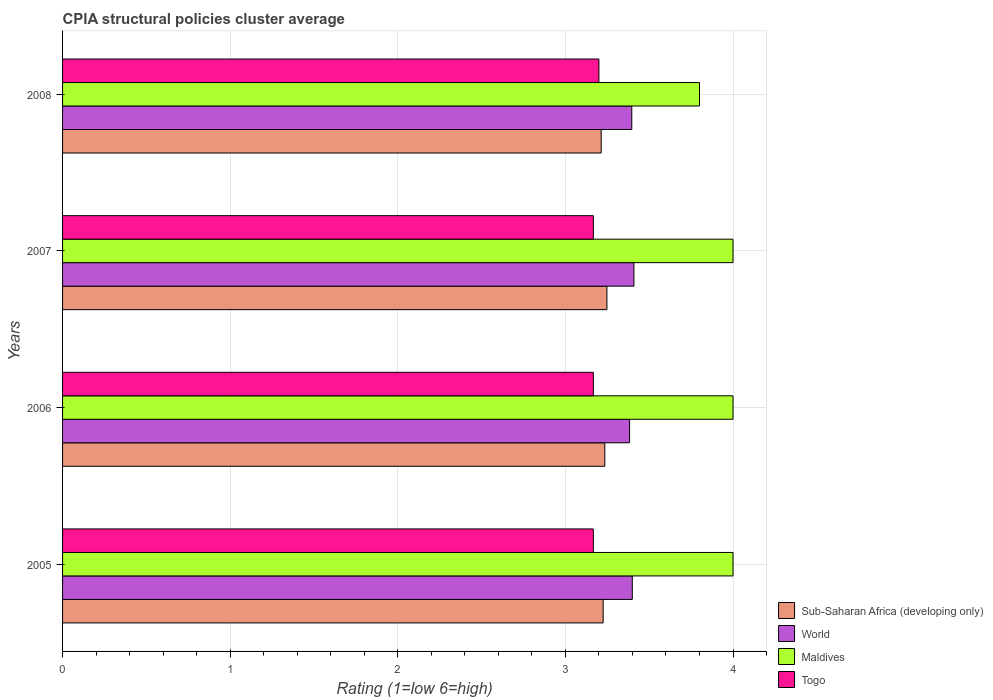How many groups of bars are there?
Your answer should be very brief. 4. Are the number of bars on each tick of the Y-axis equal?
Give a very brief answer. Yes. How many bars are there on the 4th tick from the bottom?
Offer a very short reply. 4. What is the CPIA rating in Maldives in 2005?
Your response must be concise. 4. Across all years, what is the maximum CPIA rating in Sub-Saharan Africa (developing only)?
Offer a terse response. 3.25. In which year was the CPIA rating in World maximum?
Your answer should be compact. 2007. What is the total CPIA rating in Sub-Saharan Africa (developing only) in the graph?
Make the answer very short. 12.92. What is the difference between the CPIA rating in World in 2005 and that in 2008?
Ensure brevity in your answer.  0. What is the difference between the CPIA rating in Togo in 2005 and the CPIA rating in Maldives in 2007?
Make the answer very short. -0.83. What is the average CPIA rating in World per year?
Provide a succinct answer. 3.4. In the year 2006, what is the difference between the CPIA rating in Maldives and CPIA rating in Togo?
Offer a very short reply. 0.83. In how many years, is the CPIA rating in Togo greater than 0.6000000000000001 ?
Your response must be concise. 4. What is the ratio of the CPIA rating in Togo in 2005 to that in 2008?
Offer a terse response. 0.99. Is the CPIA rating in Maldives in 2007 less than that in 2008?
Your answer should be very brief. No. What is the difference between the highest and the second highest CPIA rating in World?
Keep it short and to the point. 0.01. What is the difference between the highest and the lowest CPIA rating in Maldives?
Keep it short and to the point. 0.2. What does the 4th bar from the bottom in 2007 represents?
Offer a very short reply. Togo. How many bars are there?
Ensure brevity in your answer.  16. How many years are there in the graph?
Keep it short and to the point. 4. Does the graph contain any zero values?
Your response must be concise. No. Does the graph contain grids?
Keep it short and to the point. Yes. How are the legend labels stacked?
Make the answer very short. Vertical. What is the title of the graph?
Your answer should be compact. CPIA structural policies cluster average. What is the label or title of the X-axis?
Offer a very short reply. Rating (1=low 6=high). What is the label or title of the Y-axis?
Keep it short and to the point. Years. What is the Rating (1=low 6=high) of Sub-Saharan Africa (developing only) in 2005?
Provide a succinct answer. 3.23. What is the Rating (1=low 6=high) of World in 2005?
Ensure brevity in your answer.  3.4. What is the Rating (1=low 6=high) in Togo in 2005?
Ensure brevity in your answer.  3.17. What is the Rating (1=low 6=high) of Sub-Saharan Africa (developing only) in 2006?
Your answer should be compact. 3.24. What is the Rating (1=low 6=high) of World in 2006?
Give a very brief answer. 3.38. What is the Rating (1=low 6=high) in Togo in 2006?
Make the answer very short. 3.17. What is the Rating (1=low 6=high) in Sub-Saharan Africa (developing only) in 2007?
Keep it short and to the point. 3.25. What is the Rating (1=low 6=high) of World in 2007?
Make the answer very short. 3.41. What is the Rating (1=low 6=high) in Togo in 2007?
Ensure brevity in your answer.  3.17. What is the Rating (1=low 6=high) in Sub-Saharan Africa (developing only) in 2008?
Provide a succinct answer. 3.21. What is the Rating (1=low 6=high) of World in 2008?
Offer a very short reply. 3.4. What is the Rating (1=low 6=high) in Maldives in 2008?
Offer a very short reply. 3.8. What is the Rating (1=low 6=high) in Togo in 2008?
Offer a very short reply. 3.2. Across all years, what is the maximum Rating (1=low 6=high) in Sub-Saharan Africa (developing only)?
Your answer should be compact. 3.25. Across all years, what is the maximum Rating (1=low 6=high) of World?
Your answer should be very brief. 3.41. Across all years, what is the maximum Rating (1=low 6=high) of Togo?
Your answer should be compact. 3.2. Across all years, what is the minimum Rating (1=low 6=high) in Sub-Saharan Africa (developing only)?
Keep it short and to the point. 3.21. Across all years, what is the minimum Rating (1=low 6=high) in World?
Your response must be concise. 3.38. Across all years, what is the minimum Rating (1=low 6=high) in Maldives?
Provide a short and direct response. 3.8. Across all years, what is the minimum Rating (1=low 6=high) in Togo?
Your response must be concise. 3.17. What is the total Rating (1=low 6=high) in Sub-Saharan Africa (developing only) in the graph?
Offer a very short reply. 12.92. What is the total Rating (1=low 6=high) of World in the graph?
Give a very brief answer. 13.59. What is the difference between the Rating (1=low 6=high) in Sub-Saharan Africa (developing only) in 2005 and that in 2006?
Offer a terse response. -0.01. What is the difference between the Rating (1=low 6=high) in World in 2005 and that in 2006?
Keep it short and to the point. 0.02. What is the difference between the Rating (1=low 6=high) of Maldives in 2005 and that in 2006?
Provide a succinct answer. 0. What is the difference between the Rating (1=low 6=high) in Togo in 2005 and that in 2006?
Provide a short and direct response. 0. What is the difference between the Rating (1=low 6=high) in Sub-Saharan Africa (developing only) in 2005 and that in 2007?
Offer a very short reply. -0.02. What is the difference between the Rating (1=low 6=high) of World in 2005 and that in 2007?
Give a very brief answer. -0.01. What is the difference between the Rating (1=low 6=high) of Sub-Saharan Africa (developing only) in 2005 and that in 2008?
Make the answer very short. 0.01. What is the difference between the Rating (1=low 6=high) in World in 2005 and that in 2008?
Provide a succinct answer. 0. What is the difference between the Rating (1=low 6=high) in Togo in 2005 and that in 2008?
Your answer should be compact. -0.03. What is the difference between the Rating (1=low 6=high) in Sub-Saharan Africa (developing only) in 2006 and that in 2007?
Provide a succinct answer. -0.01. What is the difference between the Rating (1=low 6=high) of World in 2006 and that in 2007?
Provide a short and direct response. -0.03. What is the difference between the Rating (1=low 6=high) in Sub-Saharan Africa (developing only) in 2006 and that in 2008?
Keep it short and to the point. 0.02. What is the difference between the Rating (1=low 6=high) of World in 2006 and that in 2008?
Offer a terse response. -0.01. What is the difference between the Rating (1=low 6=high) of Maldives in 2006 and that in 2008?
Offer a very short reply. 0.2. What is the difference between the Rating (1=low 6=high) of Togo in 2006 and that in 2008?
Ensure brevity in your answer.  -0.03. What is the difference between the Rating (1=low 6=high) of Sub-Saharan Africa (developing only) in 2007 and that in 2008?
Your answer should be compact. 0.03. What is the difference between the Rating (1=low 6=high) of World in 2007 and that in 2008?
Your answer should be very brief. 0.01. What is the difference between the Rating (1=low 6=high) in Togo in 2007 and that in 2008?
Make the answer very short. -0.03. What is the difference between the Rating (1=low 6=high) in Sub-Saharan Africa (developing only) in 2005 and the Rating (1=low 6=high) in World in 2006?
Offer a very short reply. -0.16. What is the difference between the Rating (1=low 6=high) of Sub-Saharan Africa (developing only) in 2005 and the Rating (1=low 6=high) of Maldives in 2006?
Offer a terse response. -0.77. What is the difference between the Rating (1=low 6=high) of Sub-Saharan Africa (developing only) in 2005 and the Rating (1=low 6=high) of Togo in 2006?
Ensure brevity in your answer.  0.06. What is the difference between the Rating (1=low 6=high) in World in 2005 and the Rating (1=low 6=high) in Maldives in 2006?
Ensure brevity in your answer.  -0.6. What is the difference between the Rating (1=low 6=high) in World in 2005 and the Rating (1=low 6=high) in Togo in 2006?
Your answer should be very brief. 0.23. What is the difference between the Rating (1=low 6=high) of Sub-Saharan Africa (developing only) in 2005 and the Rating (1=low 6=high) of World in 2007?
Ensure brevity in your answer.  -0.18. What is the difference between the Rating (1=low 6=high) in Sub-Saharan Africa (developing only) in 2005 and the Rating (1=low 6=high) in Maldives in 2007?
Provide a succinct answer. -0.77. What is the difference between the Rating (1=low 6=high) in Sub-Saharan Africa (developing only) in 2005 and the Rating (1=low 6=high) in Togo in 2007?
Keep it short and to the point. 0.06. What is the difference between the Rating (1=low 6=high) of World in 2005 and the Rating (1=low 6=high) of Maldives in 2007?
Provide a succinct answer. -0.6. What is the difference between the Rating (1=low 6=high) in World in 2005 and the Rating (1=low 6=high) in Togo in 2007?
Keep it short and to the point. 0.23. What is the difference between the Rating (1=low 6=high) of Maldives in 2005 and the Rating (1=low 6=high) of Togo in 2007?
Offer a very short reply. 0.83. What is the difference between the Rating (1=low 6=high) of Sub-Saharan Africa (developing only) in 2005 and the Rating (1=low 6=high) of World in 2008?
Make the answer very short. -0.17. What is the difference between the Rating (1=low 6=high) in Sub-Saharan Africa (developing only) in 2005 and the Rating (1=low 6=high) in Maldives in 2008?
Ensure brevity in your answer.  -0.57. What is the difference between the Rating (1=low 6=high) in Sub-Saharan Africa (developing only) in 2005 and the Rating (1=low 6=high) in Togo in 2008?
Your response must be concise. 0.03. What is the difference between the Rating (1=low 6=high) of World in 2005 and the Rating (1=low 6=high) of Maldives in 2008?
Make the answer very short. -0.4. What is the difference between the Rating (1=low 6=high) in World in 2005 and the Rating (1=low 6=high) in Togo in 2008?
Keep it short and to the point. 0.2. What is the difference between the Rating (1=low 6=high) in Maldives in 2005 and the Rating (1=low 6=high) in Togo in 2008?
Make the answer very short. 0.8. What is the difference between the Rating (1=low 6=high) in Sub-Saharan Africa (developing only) in 2006 and the Rating (1=low 6=high) in World in 2007?
Provide a succinct answer. -0.17. What is the difference between the Rating (1=low 6=high) in Sub-Saharan Africa (developing only) in 2006 and the Rating (1=low 6=high) in Maldives in 2007?
Provide a succinct answer. -0.76. What is the difference between the Rating (1=low 6=high) of Sub-Saharan Africa (developing only) in 2006 and the Rating (1=low 6=high) of Togo in 2007?
Provide a succinct answer. 0.07. What is the difference between the Rating (1=low 6=high) in World in 2006 and the Rating (1=low 6=high) in Maldives in 2007?
Your response must be concise. -0.62. What is the difference between the Rating (1=low 6=high) in World in 2006 and the Rating (1=low 6=high) in Togo in 2007?
Your response must be concise. 0.22. What is the difference between the Rating (1=low 6=high) of Sub-Saharan Africa (developing only) in 2006 and the Rating (1=low 6=high) of World in 2008?
Keep it short and to the point. -0.16. What is the difference between the Rating (1=low 6=high) of Sub-Saharan Africa (developing only) in 2006 and the Rating (1=low 6=high) of Maldives in 2008?
Your answer should be compact. -0.56. What is the difference between the Rating (1=low 6=high) of Sub-Saharan Africa (developing only) in 2006 and the Rating (1=low 6=high) of Togo in 2008?
Your answer should be compact. 0.04. What is the difference between the Rating (1=low 6=high) in World in 2006 and the Rating (1=low 6=high) in Maldives in 2008?
Provide a short and direct response. -0.42. What is the difference between the Rating (1=low 6=high) of World in 2006 and the Rating (1=low 6=high) of Togo in 2008?
Your answer should be very brief. 0.18. What is the difference between the Rating (1=low 6=high) of Sub-Saharan Africa (developing only) in 2007 and the Rating (1=low 6=high) of World in 2008?
Your response must be concise. -0.15. What is the difference between the Rating (1=low 6=high) of Sub-Saharan Africa (developing only) in 2007 and the Rating (1=low 6=high) of Maldives in 2008?
Give a very brief answer. -0.55. What is the difference between the Rating (1=low 6=high) in Sub-Saharan Africa (developing only) in 2007 and the Rating (1=low 6=high) in Togo in 2008?
Provide a succinct answer. 0.05. What is the difference between the Rating (1=low 6=high) of World in 2007 and the Rating (1=low 6=high) of Maldives in 2008?
Provide a succinct answer. -0.39. What is the difference between the Rating (1=low 6=high) in World in 2007 and the Rating (1=low 6=high) in Togo in 2008?
Provide a short and direct response. 0.21. What is the average Rating (1=low 6=high) in Sub-Saharan Africa (developing only) per year?
Offer a very short reply. 3.23. What is the average Rating (1=low 6=high) in World per year?
Your answer should be very brief. 3.4. What is the average Rating (1=low 6=high) in Maldives per year?
Provide a succinct answer. 3.95. What is the average Rating (1=low 6=high) of Togo per year?
Offer a terse response. 3.17. In the year 2005, what is the difference between the Rating (1=low 6=high) in Sub-Saharan Africa (developing only) and Rating (1=low 6=high) in World?
Make the answer very short. -0.17. In the year 2005, what is the difference between the Rating (1=low 6=high) in Sub-Saharan Africa (developing only) and Rating (1=low 6=high) in Maldives?
Keep it short and to the point. -0.77. In the year 2005, what is the difference between the Rating (1=low 6=high) of Sub-Saharan Africa (developing only) and Rating (1=low 6=high) of Togo?
Provide a succinct answer. 0.06. In the year 2005, what is the difference between the Rating (1=low 6=high) in World and Rating (1=low 6=high) in Maldives?
Keep it short and to the point. -0.6. In the year 2005, what is the difference between the Rating (1=low 6=high) in World and Rating (1=low 6=high) in Togo?
Make the answer very short. 0.23. In the year 2006, what is the difference between the Rating (1=low 6=high) of Sub-Saharan Africa (developing only) and Rating (1=low 6=high) of World?
Offer a terse response. -0.15. In the year 2006, what is the difference between the Rating (1=low 6=high) in Sub-Saharan Africa (developing only) and Rating (1=low 6=high) in Maldives?
Provide a succinct answer. -0.76. In the year 2006, what is the difference between the Rating (1=low 6=high) of Sub-Saharan Africa (developing only) and Rating (1=low 6=high) of Togo?
Provide a succinct answer. 0.07. In the year 2006, what is the difference between the Rating (1=low 6=high) in World and Rating (1=low 6=high) in Maldives?
Your answer should be compact. -0.62. In the year 2006, what is the difference between the Rating (1=low 6=high) of World and Rating (1=low 6=high) of Togo?
Make the answer very short. 0.22. In the year 2006, what is the difference between the Rating (1=low 6=high) in Maldives and Rating (1=low 6=high) in Togo?
Make the answer very short. 0.83. In the year 2007, what is the difference between the Rating (1=low 6=high) in Sub-Saharan Africa (developing only) and Rating (1=low 6=high) in World?
Your answer should be compact. -0.16. In the year 2007, what is the difference between the Rating (1=low 6=high) in Sub-Saharan Africa (developing only) and Rating (1=low 6=high) in Maldives?
Keep it short and to the point. -0.75. In the year 2007, what is the difference between the Rating (1=low 6=high) in Sub-Saharan Africa (developing only) and Rating (1=low 6=high) in Togo?
Your answer should be very brief. 0.08. In the year 2007, what is the difference between the Rating (1=low 6=high) of World and Rating (1=low 6=high) of Maldives?
Offer a very short reply. -0.59. In the year 2007, what is the difference between the Rating (1=low 6=high) in World and Rating (1=low 6=high) in Togo?
Offer a terse response. 0.24. In the year 2008, what is the difference between the Rating (1=low 6=high) in Sub-Saharan Africa (developing only) and Rating (1=low 6=high) in World?
Offer a terse response. -0.18. In the year 2008, what is the difference between the Rating (1=low 6=high) of Sub-Saharan Africa (developing only) and Rating (1=low 6=high) of Maldives?
Give a very brief answer. -0.59. In the year 2008, what is the difference between the Rating (1=low 6=high) in Sub-Saharan Africa (developing only) and Rating (1=low 6=high) in Togo?
Ensure brevity in your answer.  0.01. In the year 2008, what is the difference between the Rating (1=low 6=high) of World and Rating (1=low 6=high) of Maldives?
Your answer should be compact. -0.4. In the year 2008, what is the difference between the Rating (1=low 6=high) of World and Rating (1=low 6=high) of Togo?
Offer a very short reply. 0.2. In the year 2008, what is the difference between the Rating (1=low 6=high) in Maldives and Rating (1=low 6=high) in Togo?
Your answer should be very brief. 0.6. What is the ratio of the Rating (1=low 6=high) in Sub-Saharan Africa (developing only) in 2005 to that in 2006?
Provide a succinct answer. 1. What is the ratio of the Rating (1=low 6=high) in Maldives in 2005 to that in 2006?
Keep it short and to the point. 1. What is the ratio of the Rating (1=low 6=high) in Sub-Saharan Africa (developing only) in 2005 to that in 2007?
Your response must be concise. 0.99. What is the ratio of the Rating (1=low 6=high) in Maldives in 2005 to that in 2007?
Offer a very short reply. 1. What is the ratio of the Rating (1=low 6=high) of Sub-Saharan Africa (developing only) in 2005 to that in 2008?
Keep it short and to the point. 1. What is the ratio of the Rating (1=low 6=high) in Maldives in 2005 to that in 2008?
Your answer should be very brief. 1.05. What is the ratio of the Rating (1=low 6=high) of Togo in 2006 to that in 2007?
Offer a terse response. 1. What is the ratio of the Rating (1=low 6=high) in Maldives in 2006 to that in 2008?
Provide a short and direct response. 1.05. What is the ratio of the Rating (1=low 6=high) in Sub-Saharan Africa (developing only) in 2007 to that in 2008?
Ensure brevity in your answer.  1.01. What is the ratio of the Rating (1=low 6=high) in Maldives in 2007 to that in 2008?
Provide a succinct answer. 1.05. What is the difference between the highest and the second highest Rating (1=low 6=high) in Sub-Saharan Africa (developing only)?
Provide a succinct answer. 0.01. What is the difference between the highest and the second highest Rating (1=low 6=high) of World?
Give a very brief answer. 0.01. What is the difference between the highest and the second highest Rating (1=low 6=high) in Maldives?
Give a very brief answer. 0. What is the difference between the highest and the second highest Rating (1=low 6=high) of Togo?
Offer a very short reply. 0.03. What is the difference between the highest and the lowest Rating (1=low 6=high) in Sub-Saharan Africa (developing only)?
Your answer should be compact. 0.03. What is the difference between the highest and the lowest Rating (1=low 6=high) of World?
Offer a terse response. 0.03. What is the difference between the highest and the lowest Rating (1=low 6=high) in Maldives?
Make the answer very short. 0.2. What is the difference between the highest and the lowest Rating (1=low 6=high) in Togo?
Offer a terse response. 0.03. 